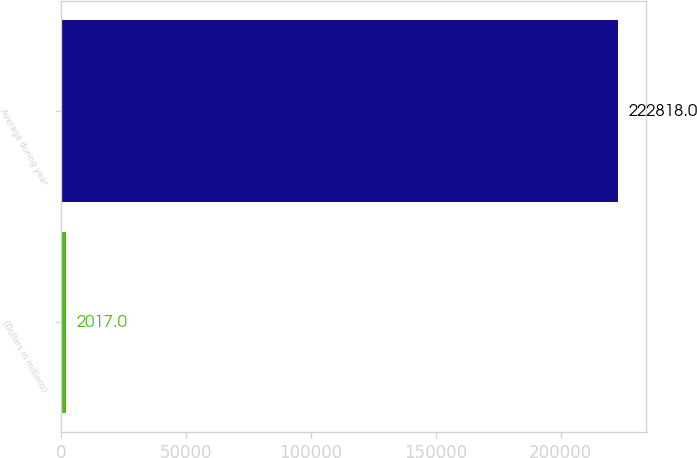Convert chart to OTSL. <chart><loc_0><loc_0><loc_500><loc_500><bar_chart><fcel>(Dollars in millions)<fcel>Average during year<nl><fcel>2017<fcel>222818<nl></chart> 